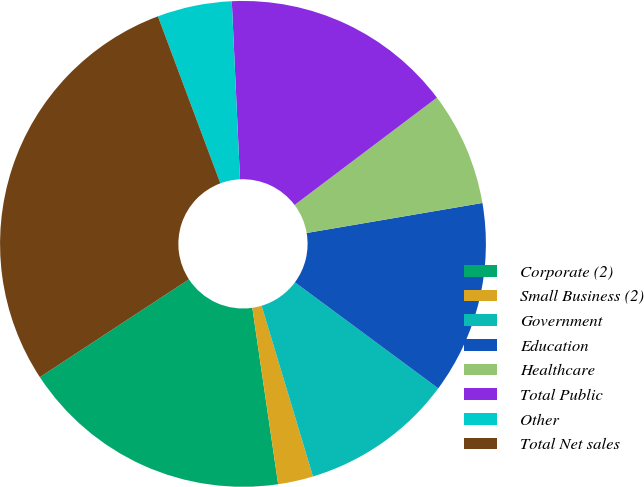Convert chart. <chart><loc_0><loc_0><loc_500><loc_500><pie_chart><fcel>Corporate (2)<fcel>Small Business (2)<fcel>Government<fcel>Education<fcel>Healthcare<fcel>Total Public<fcel>Other<fcel>Total Net sales<nl><fcel>18.07%<fcel>2.34%<fcel>10.21%<fcel>12.83%<fcel>7.59%<fcel>15.45%<fcel>4.96%<fcel>28.55%<nl></chart> 